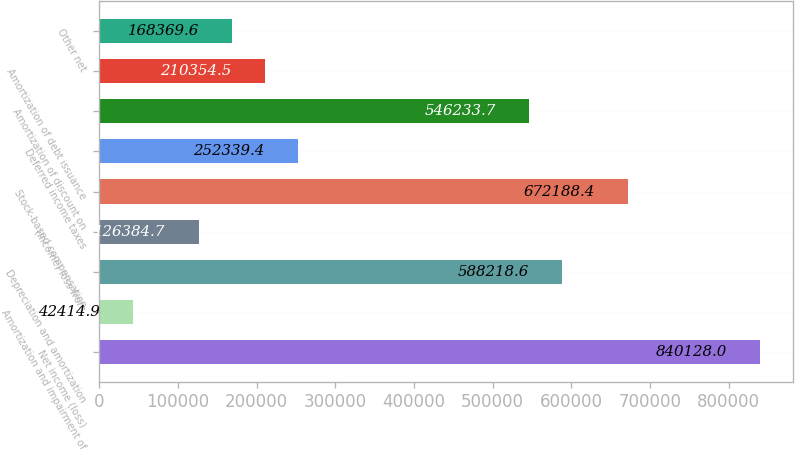Convert chart. <chart><loc_0><loc_0><loc_500><loc_500><bar_chart><fcel>Net income (loss)<fcel>Amortization and impairment of<fcel>Depreciation and amortization<fcel>(Income) loss from<fcel>Stock-based compensation<fcel>Deferred income taxes<fcel>Amortization of discount on<fcel>Amortization of debt issuance<fcel>Other net<nl><fcel>840128<fcel>42414.9<fcel>588219<fcel>126385<fcel>672188<fcel>252339<fcel>546234<fcel>210354<fcel>168370<nl></chart> 